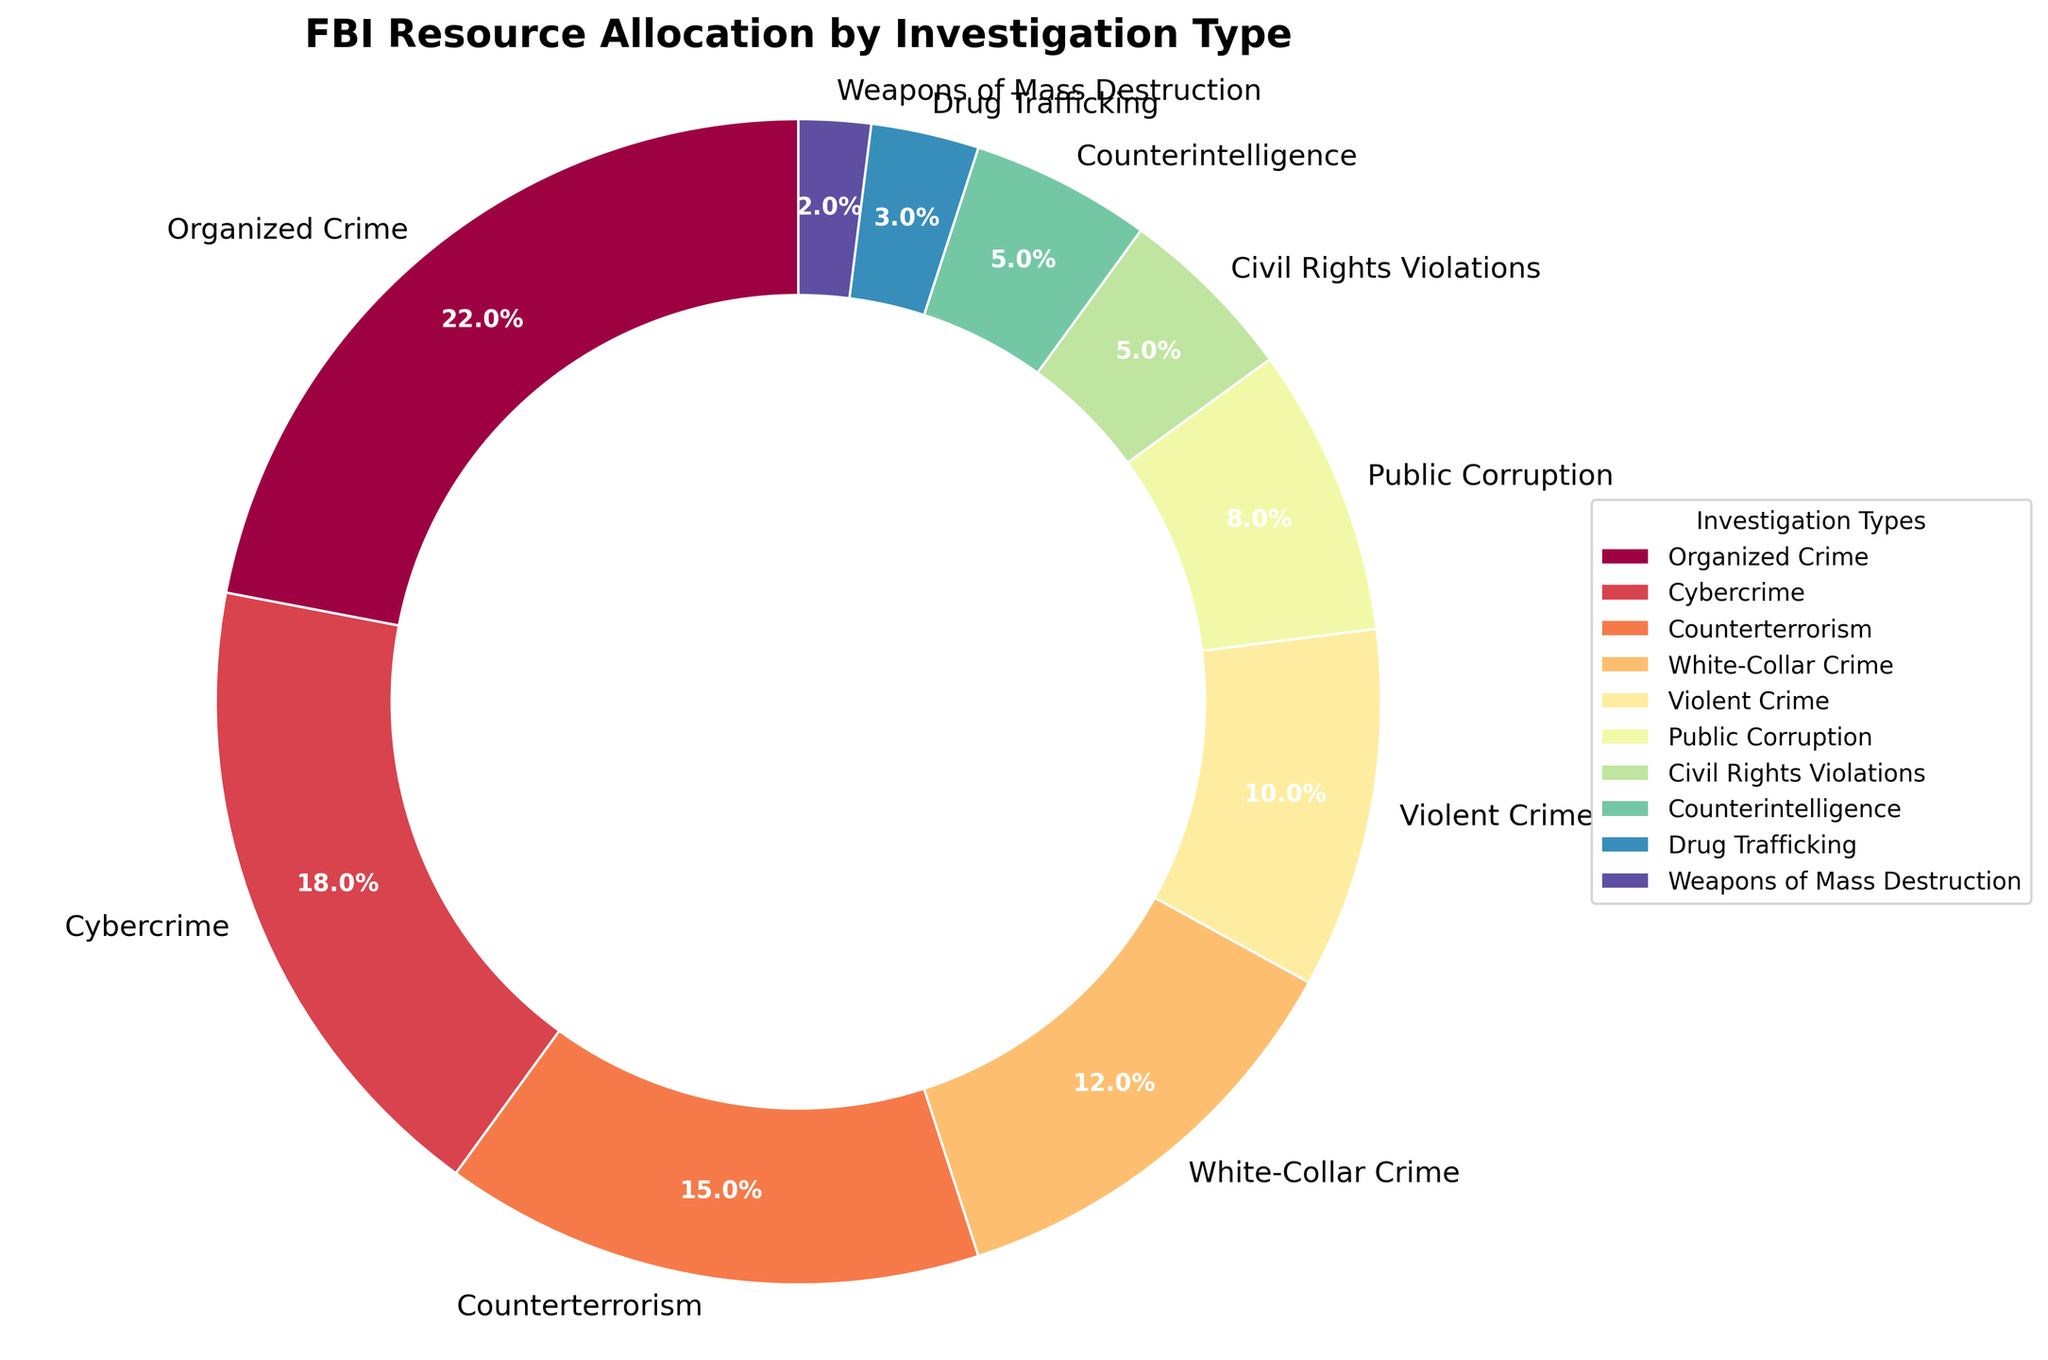What percentage of FBI resources are allocated to Organized Crime? The wedge representing "Organized Crime" shows 22% which can be read directly from the chart.
Answer: 22% Which investigation type has the smallest allocation of FBI resources? The smallest wedge in the chart is "Weapons of Mass Destruction," showing 2%, which means it has the smallest allocation of resources.
Answer: Weapons of Mass Destruction How much more percentage is allocated to Cybercrime compared to Drug Trafficking? Cybercrime is allocated 18%, and Drug Trafficking is allocated 3%. The difference is 18% - 3% = 15%.
Answer: 15% What is the combined percentage allocation for Violent Crime and Public Corruption? Violent Crime is allocated 10% and Public Corruption is allocated 8%. Combined, it's 10% + 8% = 18%.
Answer: 18% Compare the percentage of resources allocated to White-Collar Crime and Counterterrorism. Which one has a higher allocation and by how much? White-Collar Crime is allocated 12% and Counterterrorism 15%. Counterterrorism has a higher allocation by 15% - 12% = 3%.
Answer: Counterterrorism by 3% What is the total percentage allocation for Counterterrorism, Counterintelligence, and Cybercrime combined? Counterterrorism is allocated 15%, Counterintelligence 5%, and Cybercrime 18%. Combined, it's 15% + 5% + 18% = 38%.
Answer: 38% Which investigation types have an equal percentage allocation? Both Civil Rights Violations and Counterintelligence have equal percentage allocations of 5%.
Answer: Civil Rights Violations, Counterintelligence 